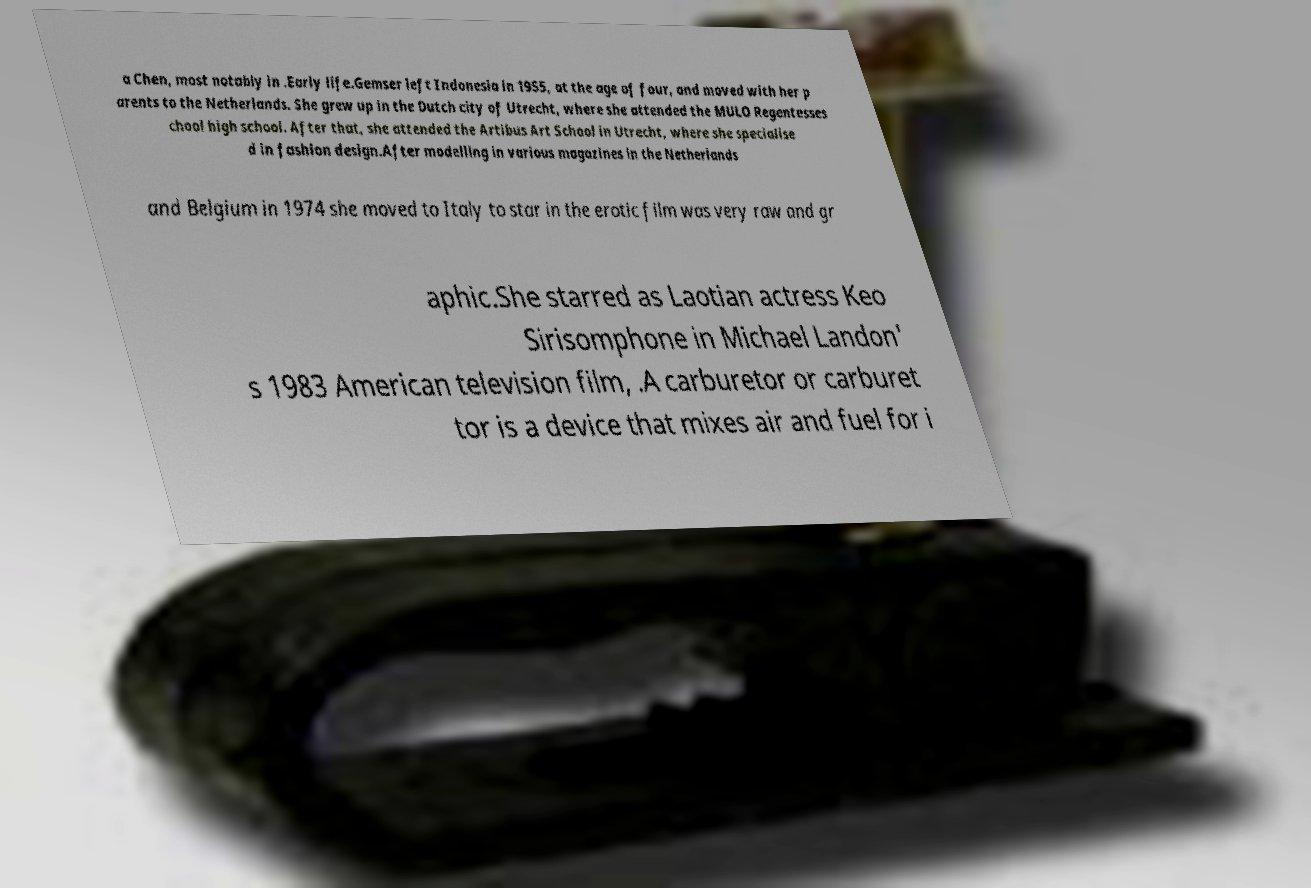What messages or text are displayed in this image? I need them in a readable, typed format. a Chen, most notably in .Early life.Gemser left Indonesia in 1955, at the age of four, and moved with her p arents to the Netherlands. She grew up in the Dutch city of Utrecht, where she attended the MULO Regentesses chool high school. After that, she attended the Artibus Art School in Utrecht, where she specialise d in fashion design.After modelling in various magazines in the Netherlands and Belgium in 1974 she moved to Italy to star in the erotic film was very raw and gr aphic.She starred as Laotian actress Keo Sirisomphone in Michael Landon' s 1983 American television film, .A carburetor or carburet tor is a device that mixes air and fuel for i 